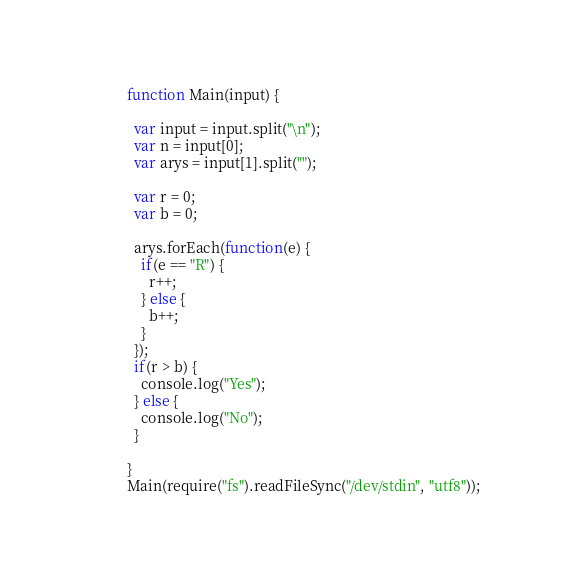<code> <loc_0><loc_0><loc_500><loc_500><_JavaScript_>function Main(input) {

  var input = input.split("\n");
  var n = input[0];
  var arys = input[1].split("");

  var r = 0;
  var b = 0;

  arys.forEach(function(e) {
    if(e == "R") {
      r++;
    } else {
      b++;
    }
  });
  if(r > b) {
    console.log("Yes");
  } else {
    console.log("No");
  }

}
Main(require("fs").readFileSync("/dev/stdin", "utf8"));</code> 